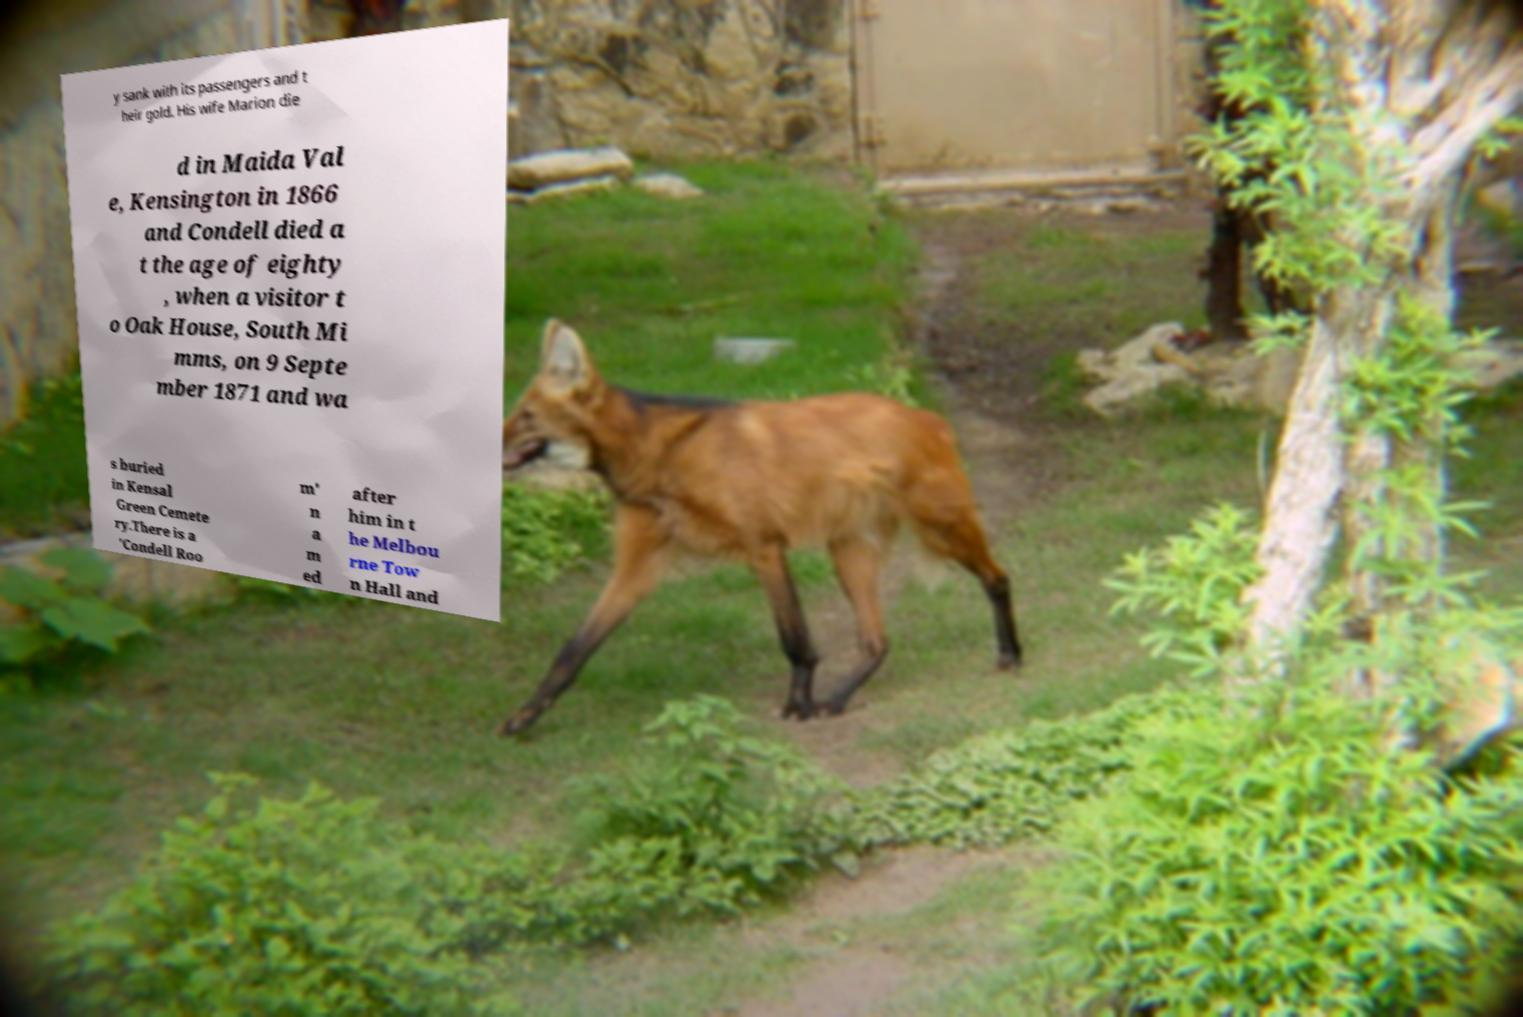Could you assist in decoding the text presented in this image and type it out clearly? y sank with its passengers and t heir gold. His wife Marion die d in Maida Val e, Kensington in 1866 and Condell died a t the age of eighty , when a visitor t o Oak House, South Mi mms, on 9 Septe mber 1871 and wa s buried in Kensal Green Cemete ry.There is a 'Condell Roo m' n a m ed after him in t he Melbou rne Tow n Hall and 